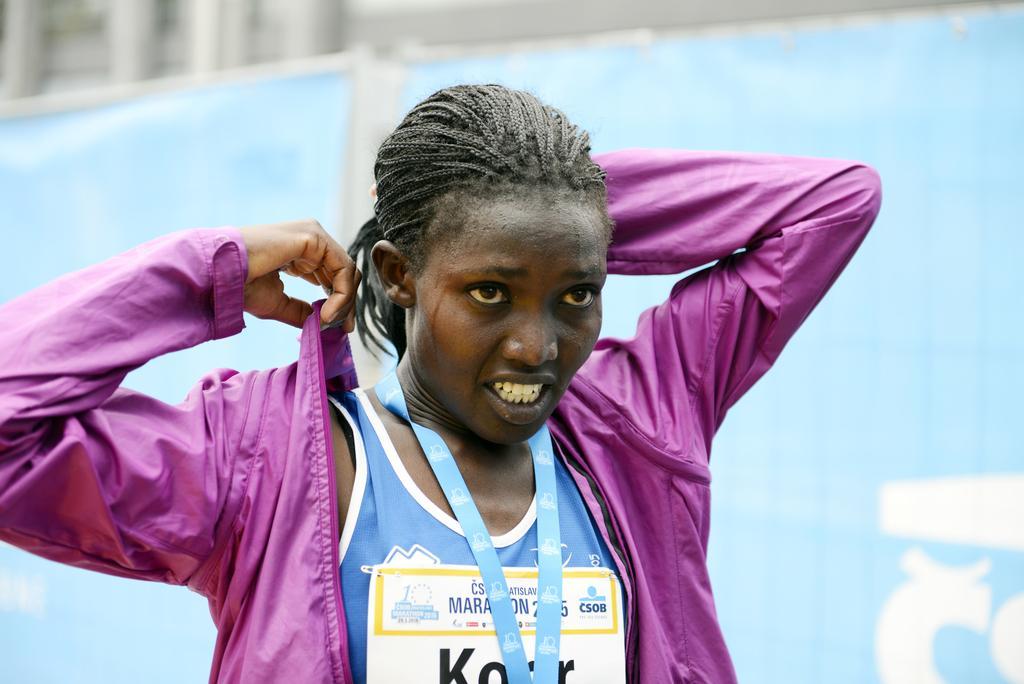Please provide a concise description of this image. As we can see in the image in the front there is a woman wearing pink color jacket. In the background there is banner and building. 